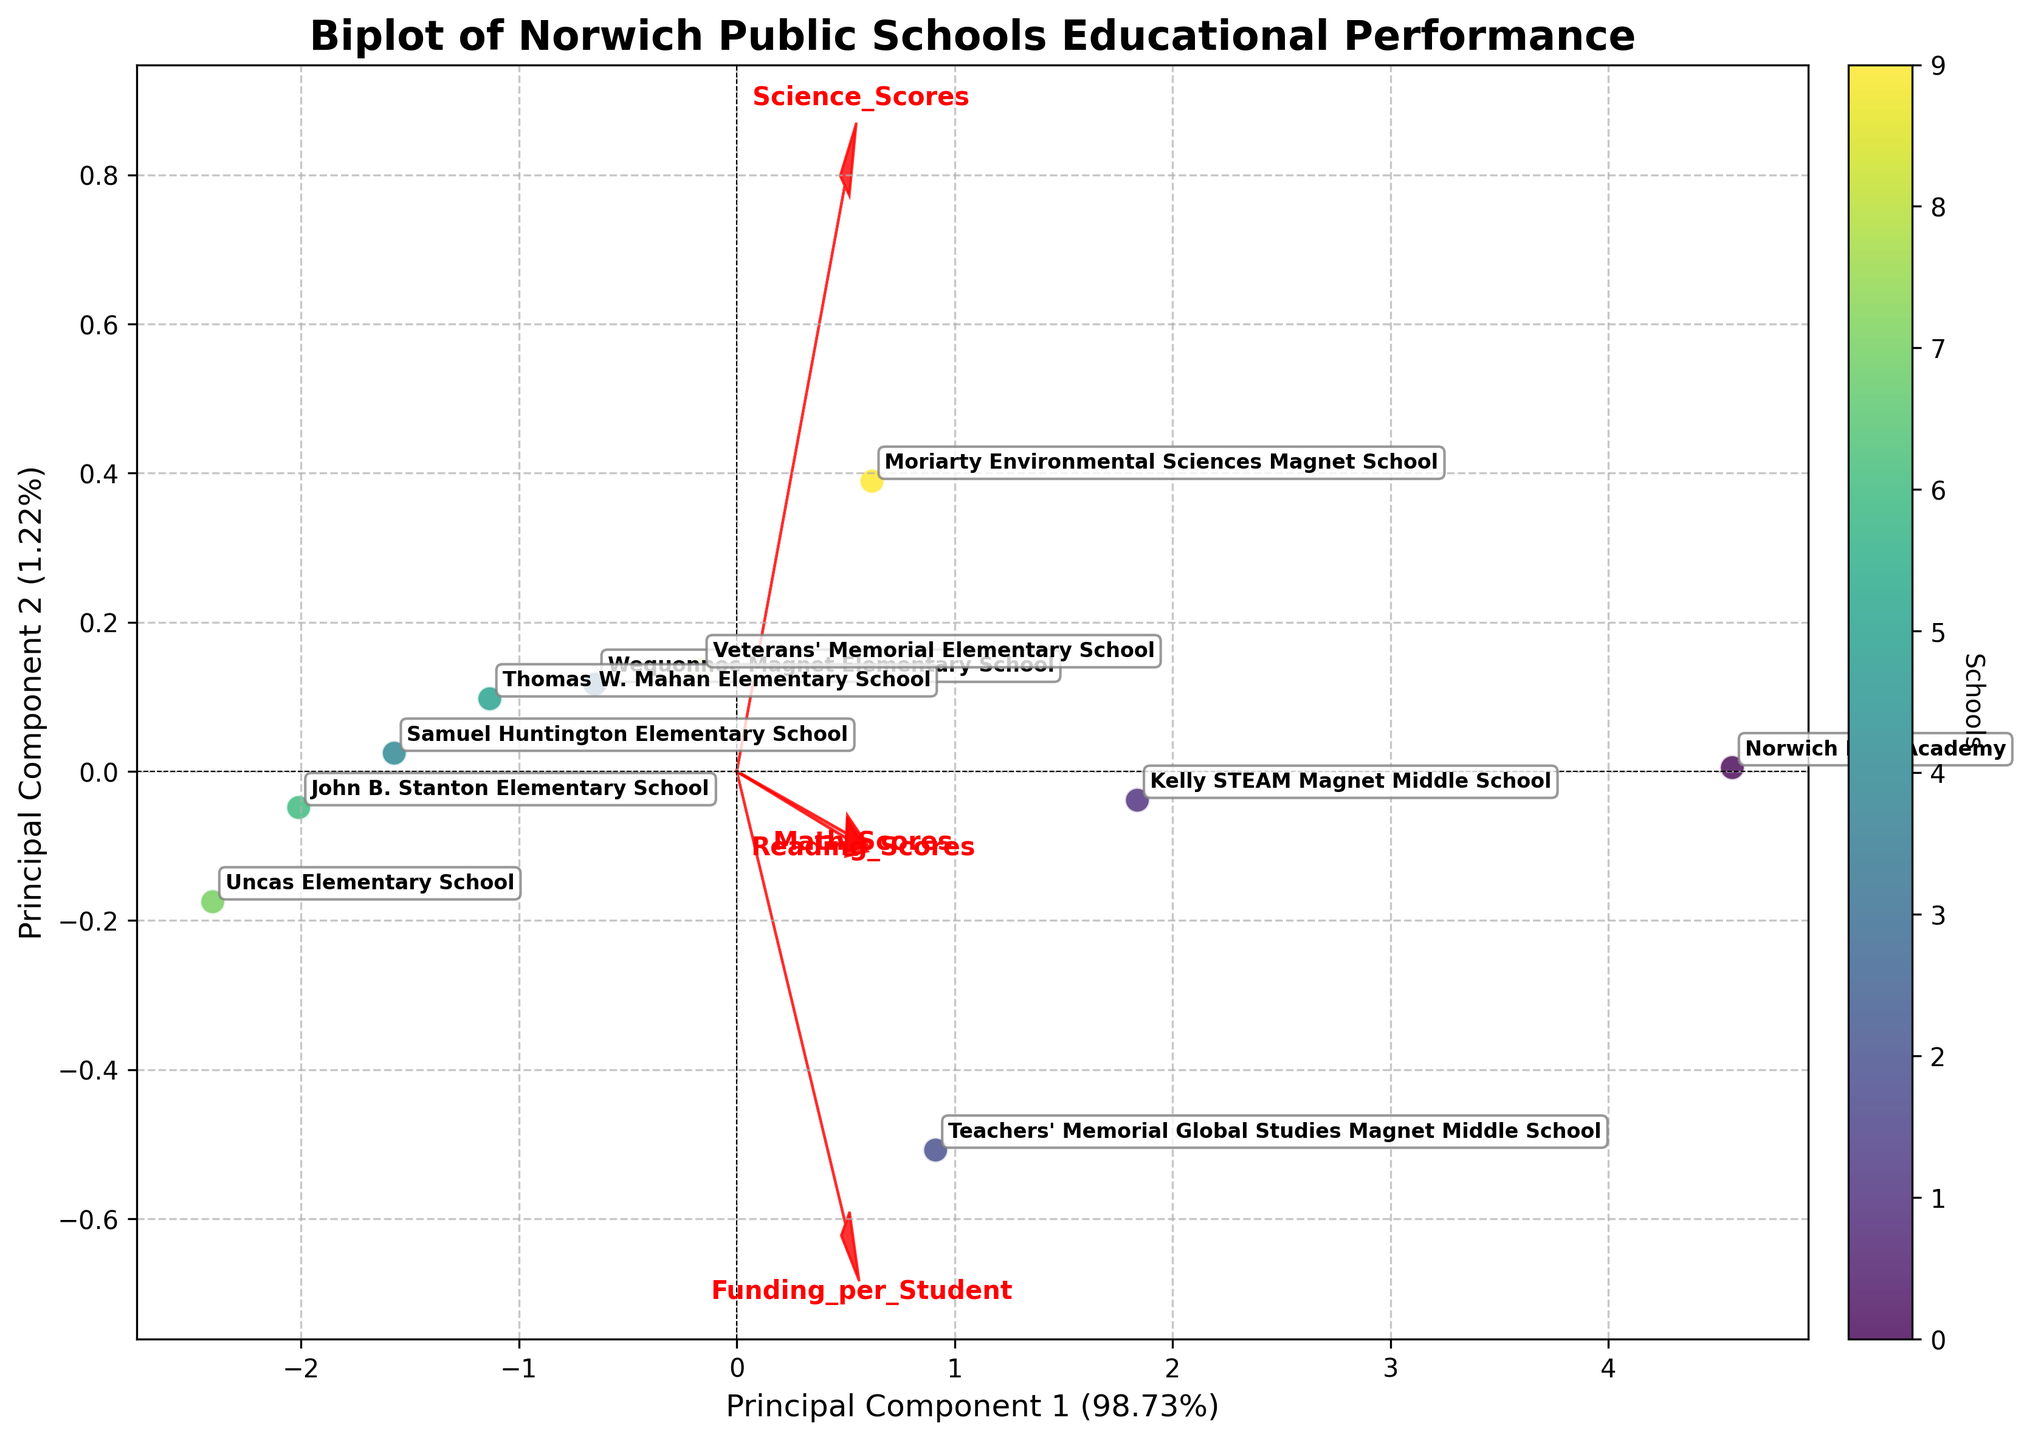What is the title of the plot? The title is found at the top of the plot and often gives the viewer a summary of what the plot is about. From the description, the title of the plot is "Biplot of Norwich Public Schools Educational Performance".
Answer: Biplot of Norwich Public Schools Educational Performance How many schools are represented in the plot? The number of schools can be inferred from the number of labeled points in the plot. Each point has been labeled with a school's name.
Answer: 10 Which school is closest to the origin in the biplot? The school closest to the origin (0,0) can be identified by looking at the labels on the points and finding the one with coordinates nearest to (0,0). This point represents the school's scores and funding scaled and transformed to the principal component axes.
Answer: John B. Stanton Elementary School Which feature has the longest arrow in the biplot? In a biplot, the length of the arrow represents the variance explained by the feature. The feature with the longest arrow is the one that has the largest spread across the principal components.
Answer: Funding_per_Student Which schools have higher Math Scores as indicated in the plot? Schools with higher Math Scores will generally lie in the direction of the arrow labeled "Math_Scores". Schools located further along this arrowhave higher values for Math Scores.
Answer: Norwich Free Academy, Kelly STEAM Magnet Middle School, and Moriarty Environmental Sciences Magnet School Which school has the highest Funding per Student? Funding per Student is one of the features represented by arrows in the plot. The school farthest along the direction of the "Funding_per_Student" arrow represents the highest value for this feature.
Answer: Norwich Free Academy How does Wequonnoc Magnet Elementary School compare to Veterans' Memorial Elementary School in terms of Principal Component 1? To compare these two schools on Principal Component 1, examine their positions along the x-axis, which represents the first principal component. The school farther to the right has a higher value for Principal Component 1.
Answer: Veterans' Memorial Elementary School is higher on Principal Component 1 Is there a visible correlation between Math Scores and Science Scores? In a biplot, correlation between features can be inferred from the angles between the corresponding arrows. Small angles suggest a positive correlation, perpendicular arrows indicate no correlation, and large angles (close to 180 degrees) indicate a negative correlation.
Answer: There is a positive correlation What percentage of the total variance is explained by Principal Component 2? This information is often included in the axis label for Principal Component 2. The label will indicate the percentage of variance explained by this component.
Answer: 19.31% Which two schools have the most similar performance and funding distribution? Similarity in performance and funding distribution can be inferred from the proximity of two points on the biplot. Points that are close to each other represent schools with similar values after normalization and transformation by PCA.
Answer: Kelly STEAM Magnet Middle School and Teachers' Memorial Global Studies Magnet Middle School 